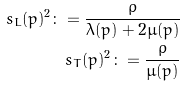Convert formula to latex. <formula><loc_0><loc_0><loc_500><loc_500>s _ { L } ( p ) ^ { 2 } \colon = \frac { \rho } { \lambda ( p ) + 2 \mu ( p ) } \\ s _ { T } ( p ) ^ { 2 } \colon = \frac { \rho } { \mu ( p ) }</formula> 